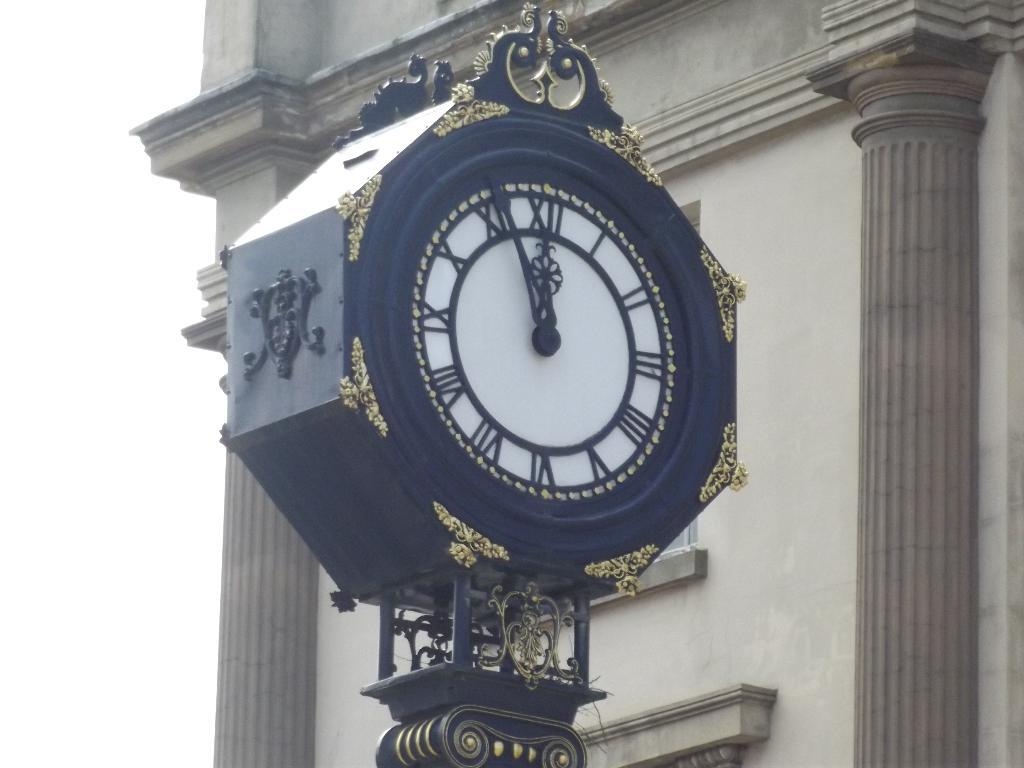What object in the image is used for measuring time? There is a clock in the image. What can be found in the middle of the image? There is a pillar in the middle of the image. What is the condition of the building in the background? There is a truncated building in the background of the image. What color is the background on the left side of the image? The background on the left side of the image is white. How many apples are on the pillar in the image? There are no apples present in the image. What type of smile can be seen on the clock in the image? There is no smile on the clock in the image, as it is an inanimate object. 